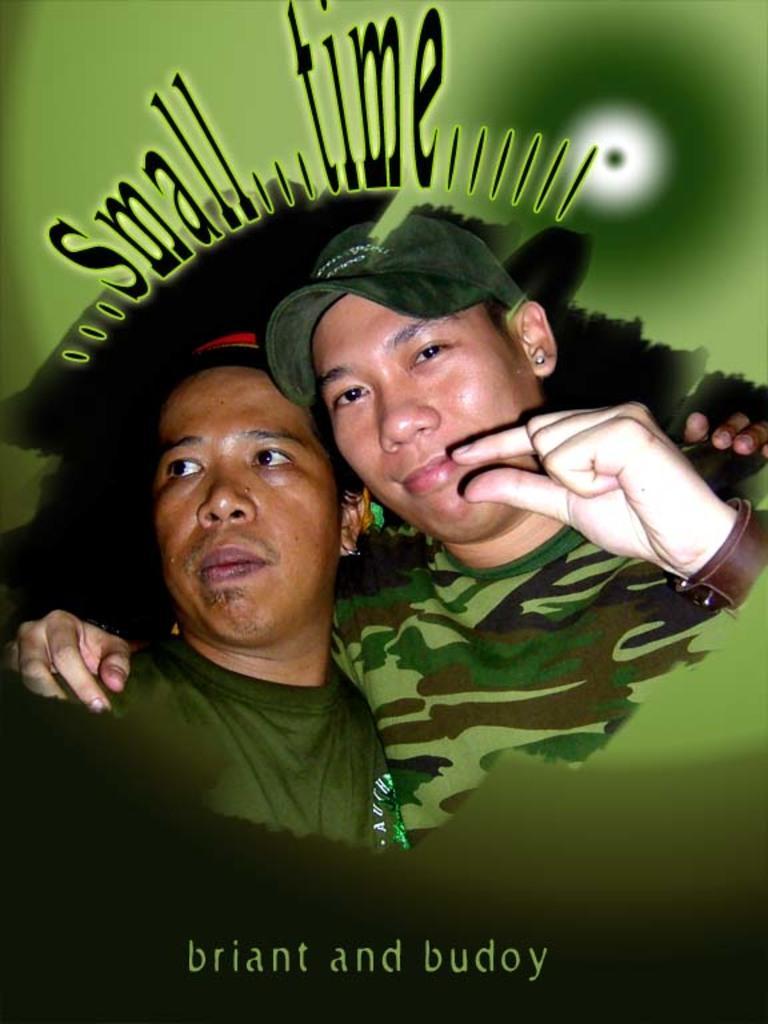Please provide a concise description of this image. This picture is an edited picture. In this image there are two persons. At the top there is a text. At the bottom there is a text. 